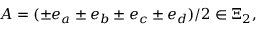Convert formula to latex. <formula><loc_0><loc_0><loc_500><loc_500>A = ( \pm e _ { a } \pm e _ { b } \pm e _ { c } \pm e _ { d } ) / 2 \in \Xi _ { 2 } ,</formula> 